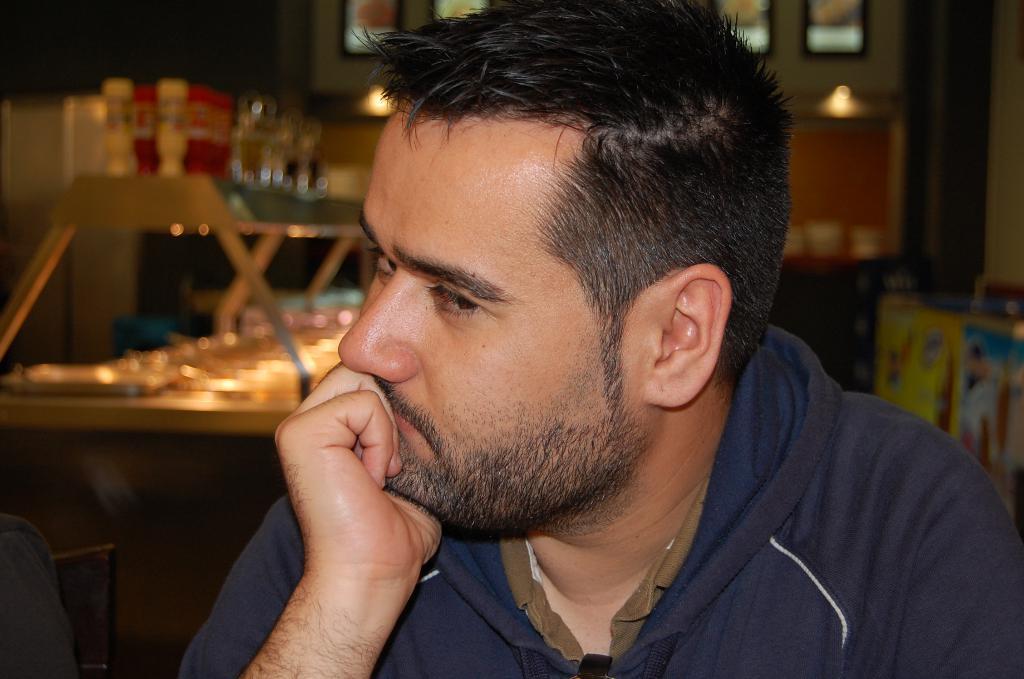In one or two sentences, can you explain what this image depicts? In this image I can see a man and I can see he is wearing hoodie. In the background I can see few stuffs and I can see this image is little bit blurry from background. 